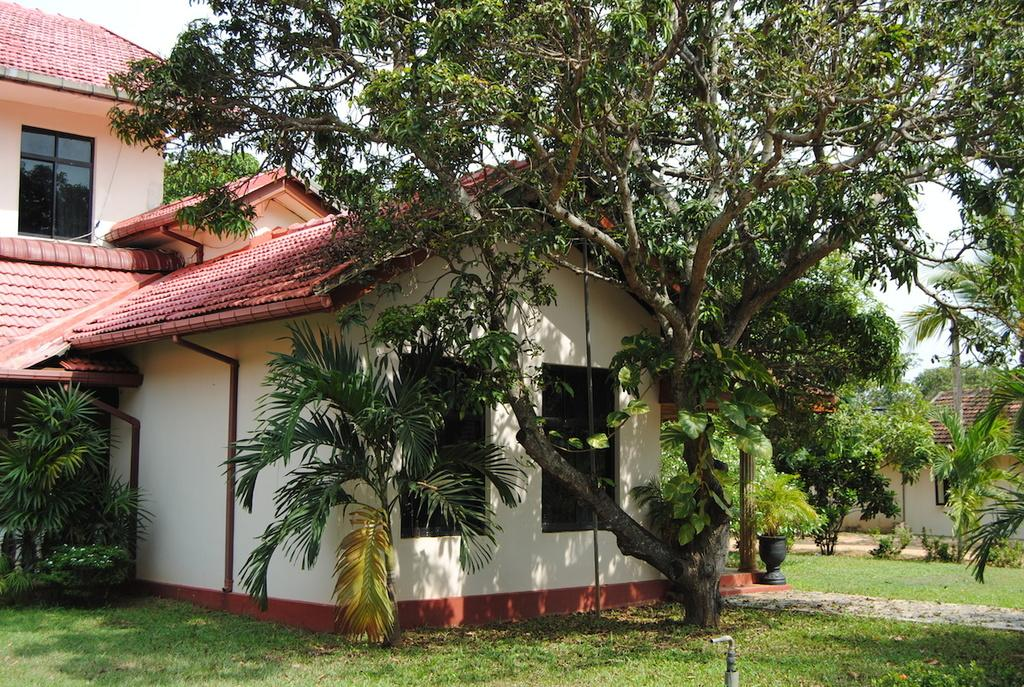What type of structure is present in the image? There is a house in the image. What features can be observed on the house? The house has a roof and windows. What type of vegetation is present in the image? There are trees and plants in the image. Is there a designated route for walking in the image? Yes, there is a pathway in the image. What part of the natural environment is visible in the image? The sky is visible in the image. How many children are playing with the gun in the yard in the image? There is no gun or children present in the image; it features a house, trees, plants, a pathway, and the sky. 